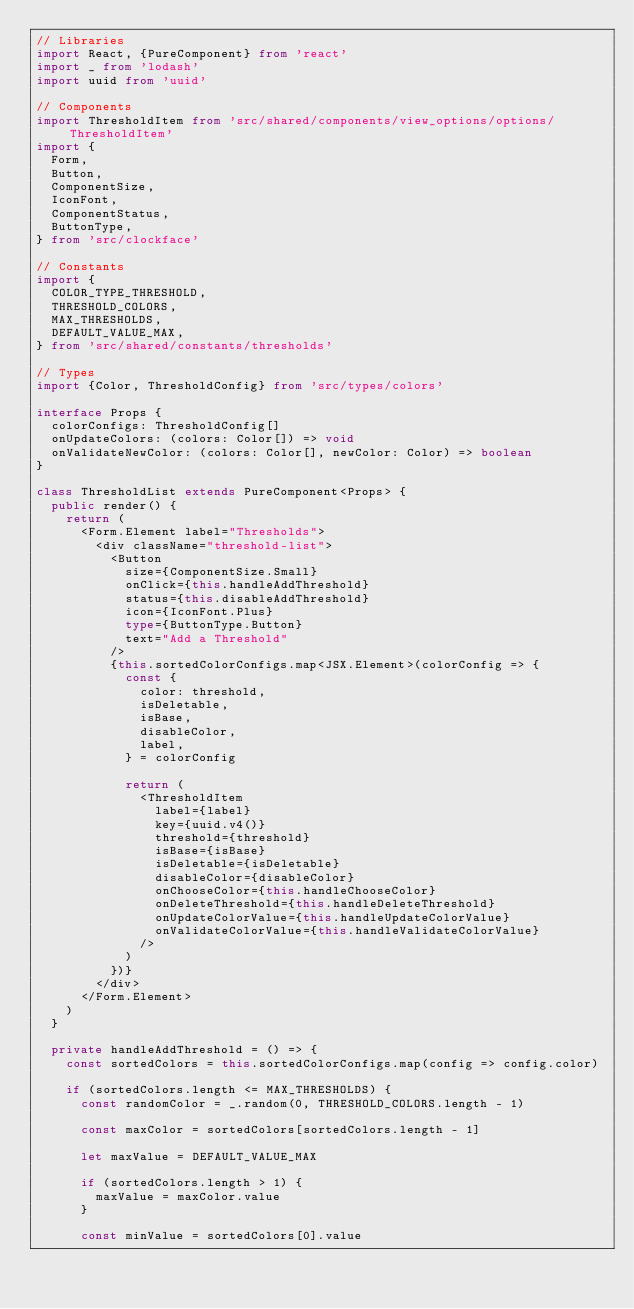Convert code to text. <code><loc_0><loc_0><loc_500><loc_500><_TypeScript_>// Libraries
import React, {PureComponent} from 'react'
import _ from 'lodash'
import uuid from 'uuid'

// Components
import ThresholdItem from 'src/shared/components/view_options/options/ThresholdItem'
import {
  Form,
  Button,
  ComponentSize,
  IconFont,
  ComponentStatus,
  ButtonType,
} from 'src/clockface'

// Constants
import {
  COLOR_TYPE_THRESHOLD,
  THRESHOLD_COLORS,
  MAX_THRESHOLDS,
  DEFAULT_VALUE_MAX,
} from 'src/shared/constants/thresholds'

// Types
import {Color, ThresholdConfig} from 'src/types/colors'

interface Props {
  colorConfigs: ThresholdConfig[]
  onUpdateColors: (colors: Color[]) => void
  onValidateNewColor: (colors: Color[], newColor: Color) => boolean
}

class ThresholdList extends PureComponent<Props> {
  public render() {
    return (
      <Form.Element label="Thresholds">
        <div className="threshold-list">
          <Button
            size={ComponentSize.Small}
            onClick={this.handleAddThreshold}
            status={this.disableAddThreshold}
            icon={IconFont.Plus}
            type={ButtonType.Button}
            text="Add a Threshold"
          />
          {this.sortedColorConfigs.map<JSX.Element>(colorConfig => {
            const {
              color: threshold,
              isDeletable,
              isBase,
              disableColor,
              label,
            } = colorConfig

            return (
              <ThresholdItem
                label={label}
                key={uuid.v4()}
                threshold={threshold}
                isBase={isBase}
                isDeletable={isDeletable}
                disableColor={disableColor}
                onChooseColor={this.handleChooseColor}
                onDeleteThreshold={this.handleDeleteThreshold}
                onUpdateColorValue={this.handleUpdateColorValue}
                onValidateColorValue={this.handleValidateColorValue}
              />
            )
          })}
        </div>
      </Form.Element>
    )
  }

  private handleAddThreshold = () => {
    const sortedColors = this.sortedColorConfigs.map(config => config.color)

    if (sortedColors.length <= MAX_THRESHOLDS) {
      const randomColor = _.random(0, THRESHOLD_COLORS.length - 1)

      const maxColor = sortedColors[sortedColors.length - 1]

      let maxValue = DEFAULT_VALUE_MAX

      if (sortedColors.length > 1) {
        maxValue = maxColor.value
      }

      const minValue = sortedColors[0].value
</code> 